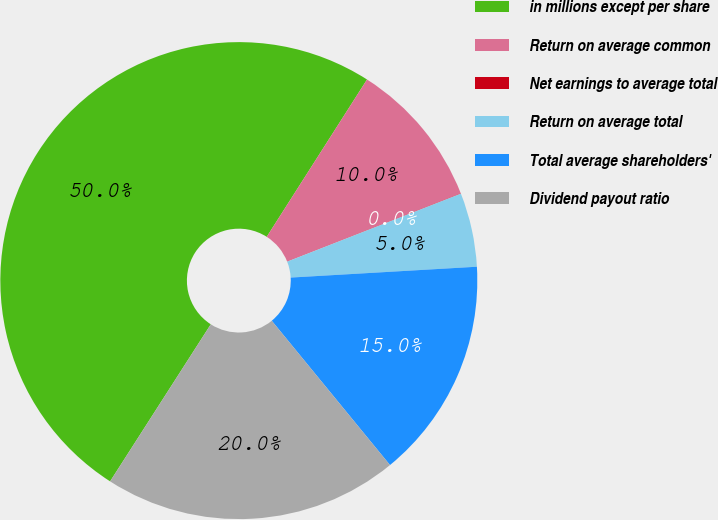Convert chart to OTSL. <chart><loc_0><loc_0><loc_500><loc_500><pie_chart><fcel>in millions except per share<fcel>Return on average common<fcel>Net earnings to average total<fcel>Return on average total<fcel>Total average shareholders'<fcel>Dividend payout ratio<nl><fcel>49.96%<fcel>10.01%<fcel>0.02%<fcel>5.01%<fcel>15.0%<fcel>20.0%<nl></chart> 